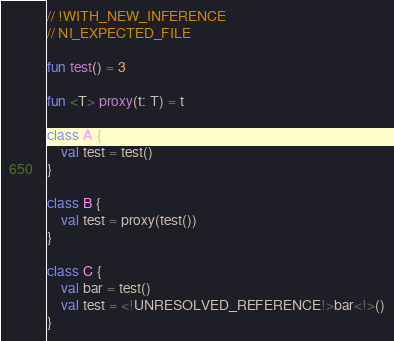<code> <loc_0><loc_0><loc_500><loc_500><_Kotlin_>// !WITH_NEW_INFERENCE
// NI_EXPECTED_FILE

fun test() = 3

fun <T> proxy(t: T) = t

class A {
    val test = test()
}

class B {
    val test = proxy(test())
}

class C {
    val bar = test()
    val test = <!UNRESOLVED_REFERENCE!>bar<!>()
}</code> 